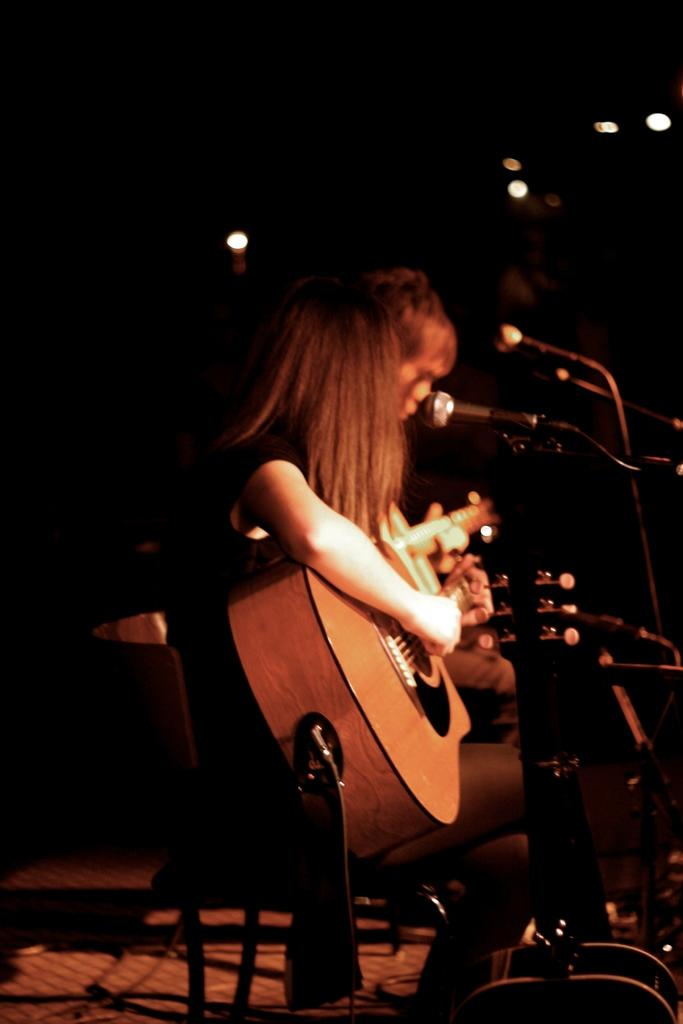What is the woman in the image doing? The woman is sitting on a chair and playing the guitar. What is the woman holding in her hand? The woman is holding a guitar in her hand. Is there anyone else in the image? Yes, there is another person sitting beside the woman. What is the other person doing? The other person is also playing a guitar. What type of island can be seen in the background of the image? There is no island visible in the background of the image. Is there a pet present in the image? There is no pet visible in the image. 